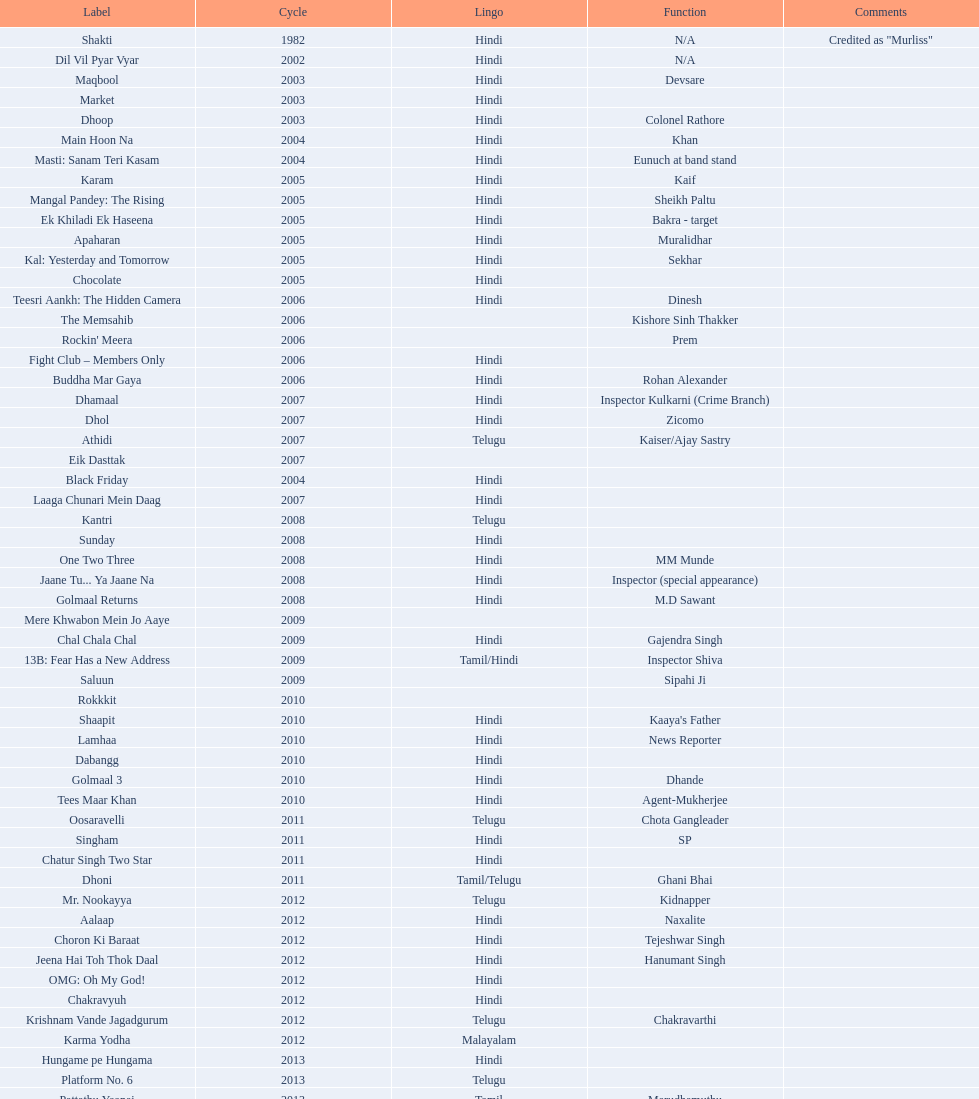What title is before dhol in 2007? Dhamaal. 